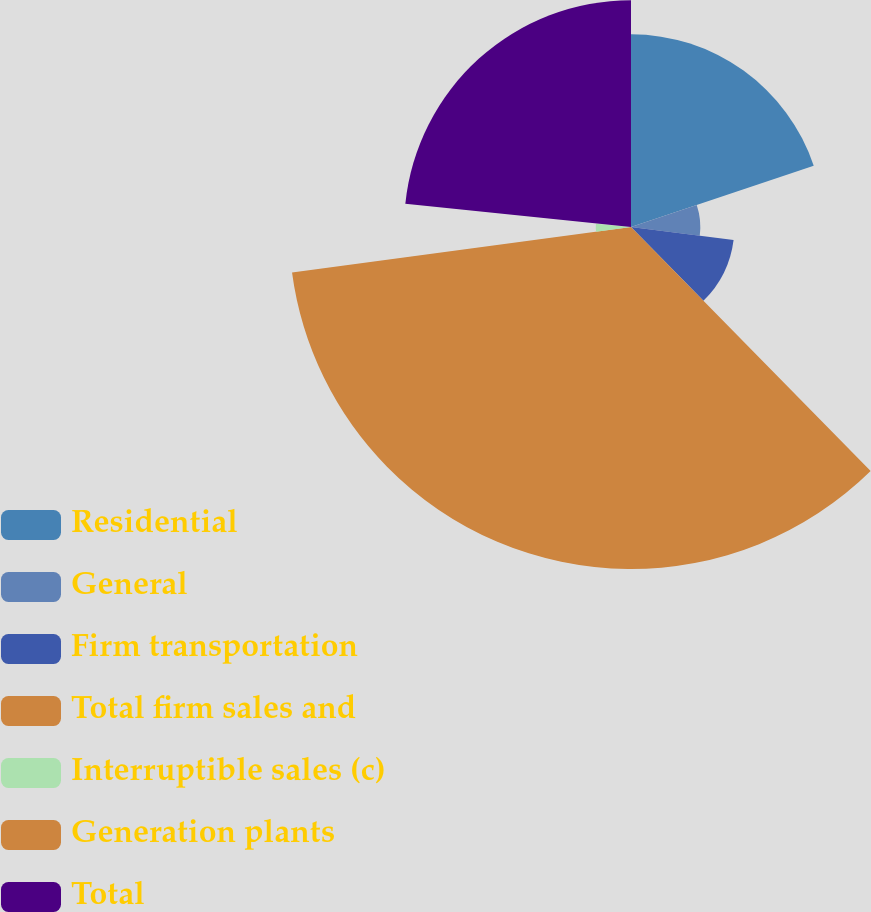Convert chart. <chart><loc_0><loc_0><loc_500><loc_500><pie_chart><fcel>Residential<fcel>General<fcel>Firm transportation<fcel>Total firm sales and<fcel>Interruptible sales (c)<fcel>Generation plants<fcel>Total<nl><fcel>19.85%<fcel>7.14%<fcel>10.65%<fcel>35.23%<fcel>3.63%<fcel>0.12%<fcel>23.37%<nl></chart> 